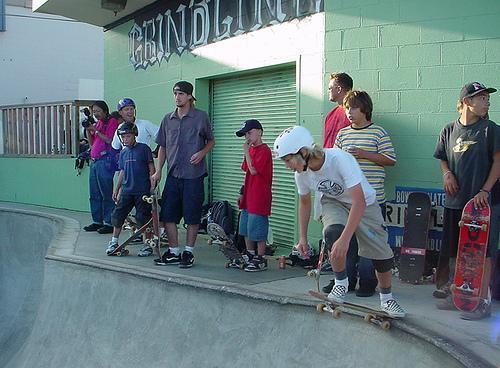What type of skate maneuver is the boy in white about to perform?
Answer the question by selecting the correct answer among the 4 following choices.
Options: Drop in, wall ride, flip, manual. Drop in. 